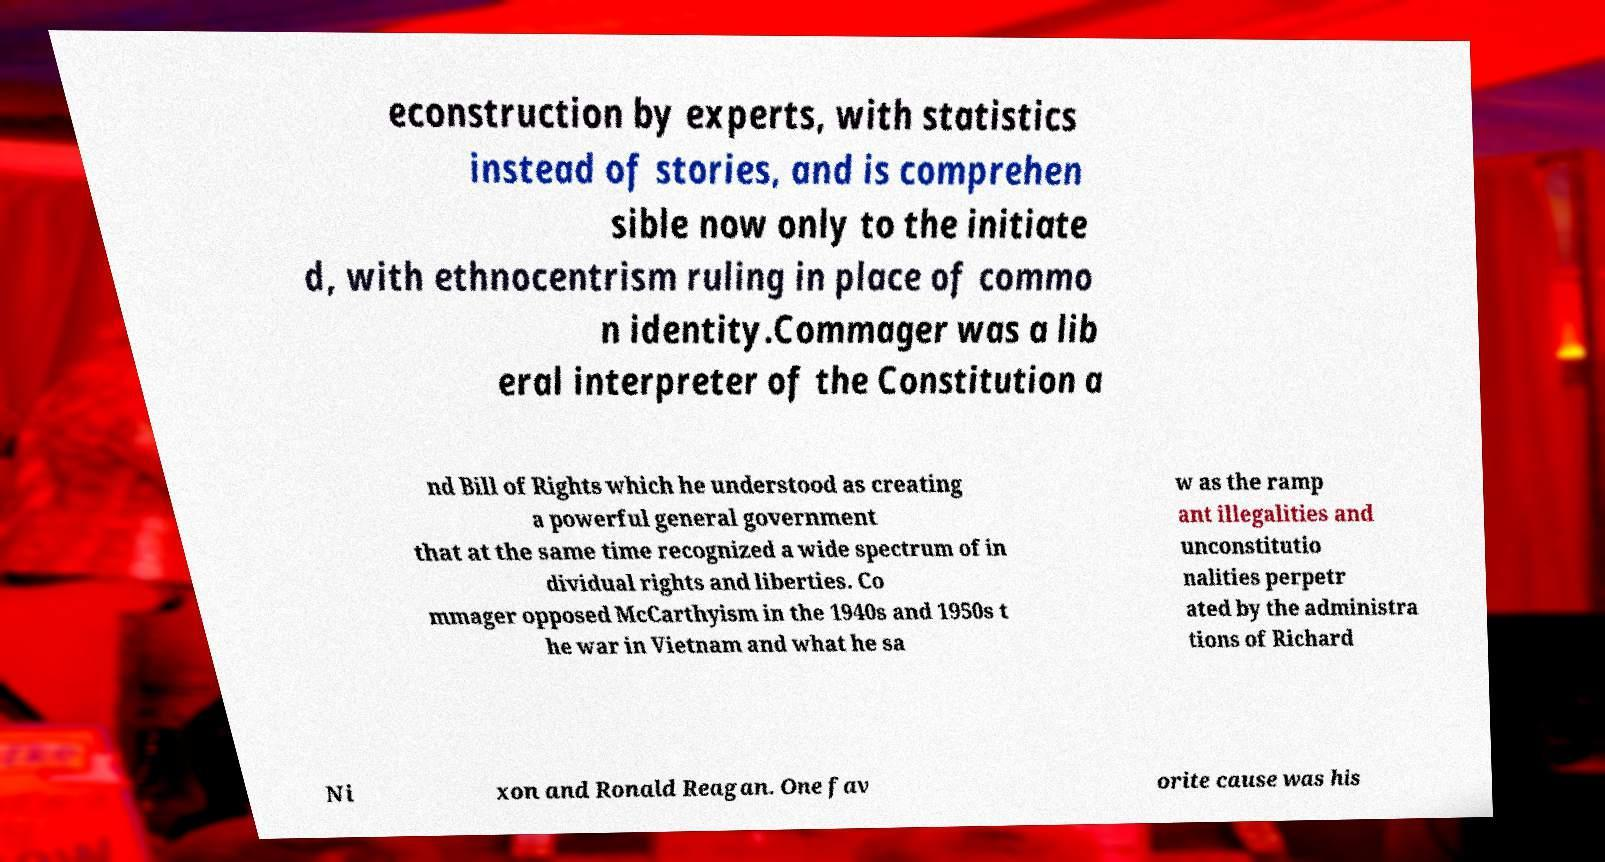I need the written content from this picture converted into text. Can you do that? econstruction by experts, with statistics instead of stories, and is comprehen sible now only to the initiate d, with ethnocentrism ruling in place of commo n identity.Commager was a lib eral interpreter of the Constitution a nd Bill of Rights which he understood as creating a powerful general government that at the same time recognized a wide spectrum of in dividual rights and liberties. Co mmager opposed McCarthyism in the 1940s and 1950s t he war in Vietnam and what he sa w as the ramp ant illegalities and unconstitutio nalities perpetr ated by the administra tions of Richard Ni xon and Ronald Reagan. One fav orite cause was his 